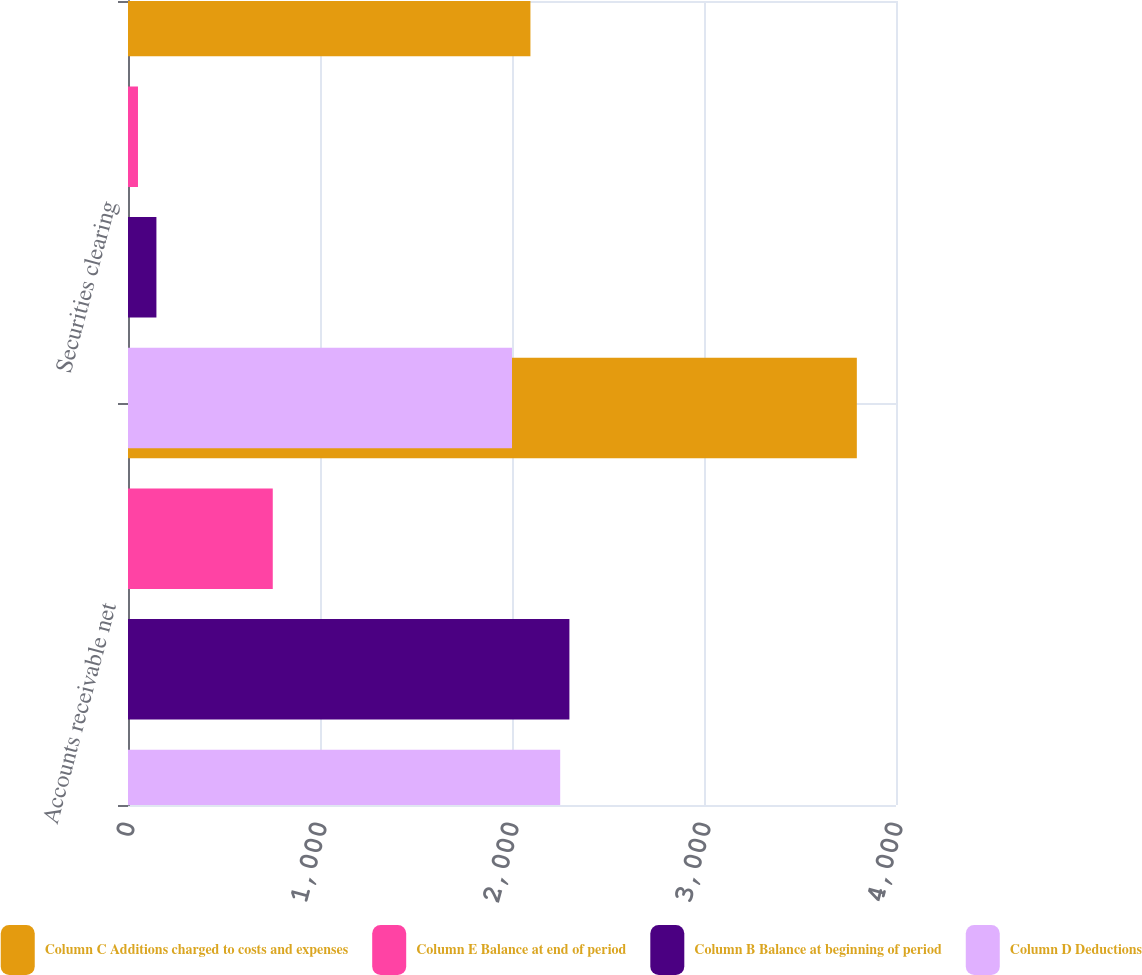Convert chart to OTSL. <chart><loc_0><loc_0><loc_500><loc_500><stacked_bar_chart><ecel><fcel>Accounts receivable net<fcel>Securities clearing<nl><fcel>Column C Additions charged to costs and expenses<fcel>3796<fcel>2096<nl><fcel>Column E Balance at end of period<fcel>754<fcel>52<nl><fcel>Column B Balance at beginning of period<fcel>2299<fcel>148<nl><fcel>Column D Deductions<fcel>2251<fcel>2000<nl></chart> 